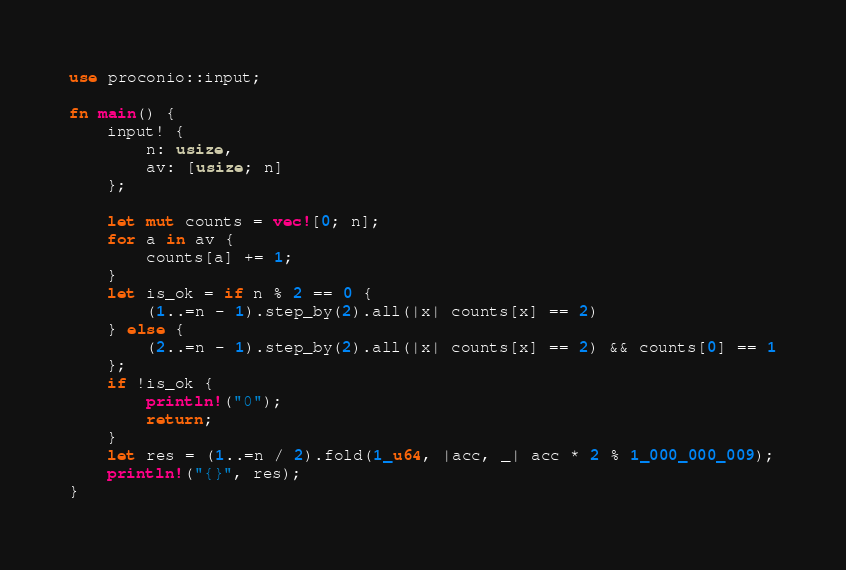Convert code to text. <code><loc_0><loc_0><loc_500><loc_500><_Rust_>use proconio::input;

fn main() {
    input! {
        n: usize,
        av: [usize; n]
    };

    let mut counts = vec![0; n];
    for a in av {
        counts[a] += 1;
    }
    let is_ok = if n % 2 == 0 {
        (1..=n - 1).step_by(2).all(|x| counts[x] == 2)
    } else {
        (2..=n - 1).step_by(2).all(|x| counts[x] == 2) && counts[0] == 1
    };
    if !is_ok {
        println!("0");
        return;
    }
    let res = (1..=n / 2).fold(1_u64, |acc, _| acc * 2 % 1_000_000_009);
    println!("{}", res);
}
</code> 